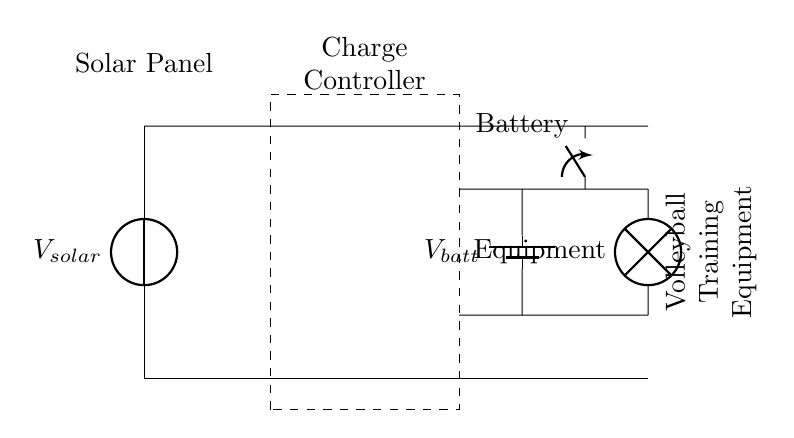What component converts sunlight into electricity? The circuit diagram shows a solar panel, which is indicated by the symbol labeled Vsolar. A solar panel converts sunlight into electrical energy.
Answer: Solar panel What is the purpose of the charge controller? The charge controller is represented by the dashed rectangle in the diagram. Its primary function is to regulate the voltage and current coming from the solar panel to the battery, ensuring safe charging and preventing overcharging.
Answer: Regulate charging How does the volleyball training equipment receive power? The equipment receives power via the connections leading from the battery. The connections from the battery to the load (equipment) indicate the flow of electrical energy to power it.
Answer: From the battery What is the voltage across the battery when charged? The battery in the circuit is labeled Vbatt, which indicates it is a source of stored electrical energy that supplies power to the load. The exact voltage would depend on the specifications of the battery used in this circuit.
Answer: Vbatt What component can disconnect the load from the circuit? The diagram includes a switch, represented by the symbol at the connection to the volleyball training equipment. The switch can open or close to disconnect the load from the battery, controlling the power supplied.
Answer: Switch How many main components are present in this circuit? The circuit comprises three main components: the solar panel, the charge controller, and the battery. Together, they facilitate the solar-powered charging functionality.
Answer: Three components 